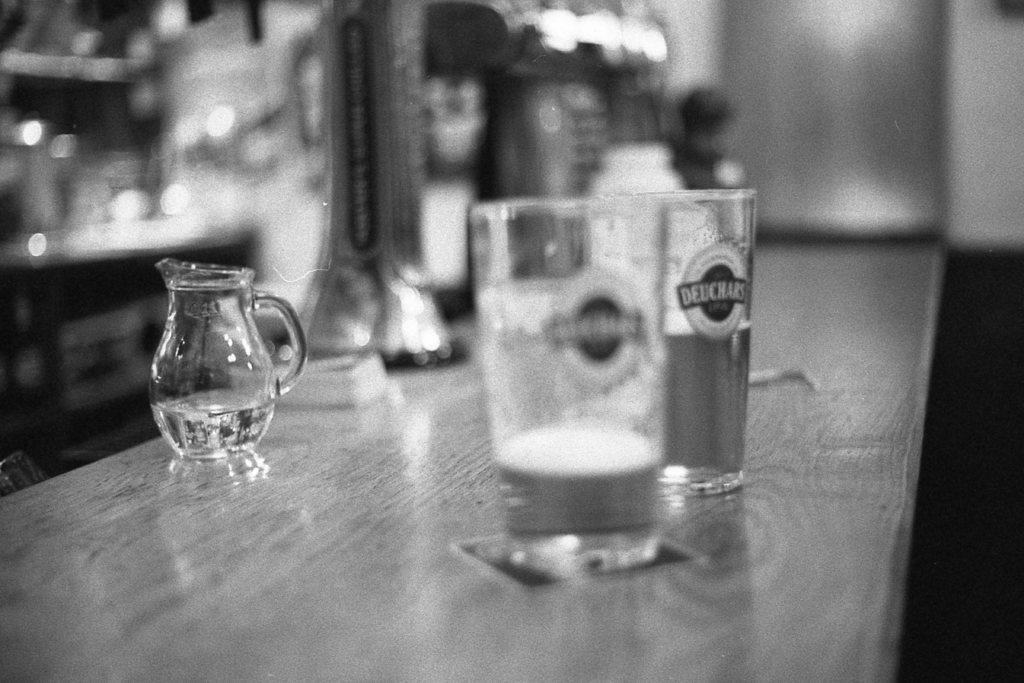Can you describe this image briefly? In this image, There is a table which i s in white color and there are some glasses on the table. 